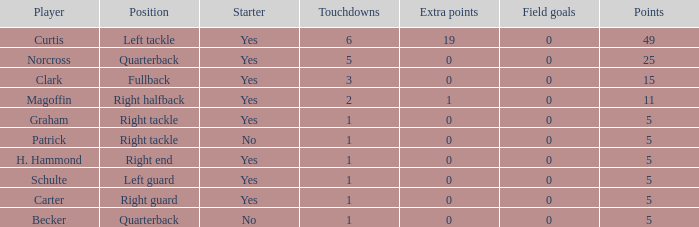Name the most touchdowns for becker  1.0. 